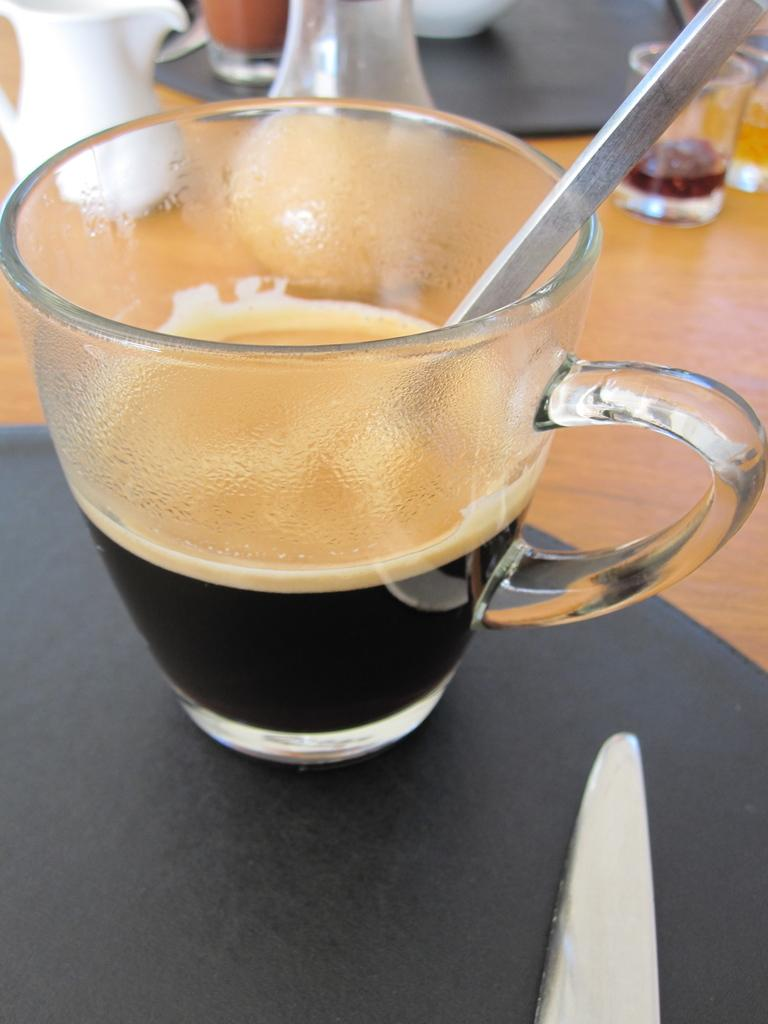What is in the cup that is visible in the image? There is a drink in the cup in the image. What is used to mix the drink in the cup? There is a stirrer in the cup. Where is the cup and stirrer located in the image? The cup and stirrer are on a surface. What other items can be seen in the background of the image? In the background, there are jugs and glasses on the surface. What type of jelly is being used to create harmony in the image? There is no jelly or reference to harmony in the image; it features a cup with a drink, a stirrer, and items in the background. 